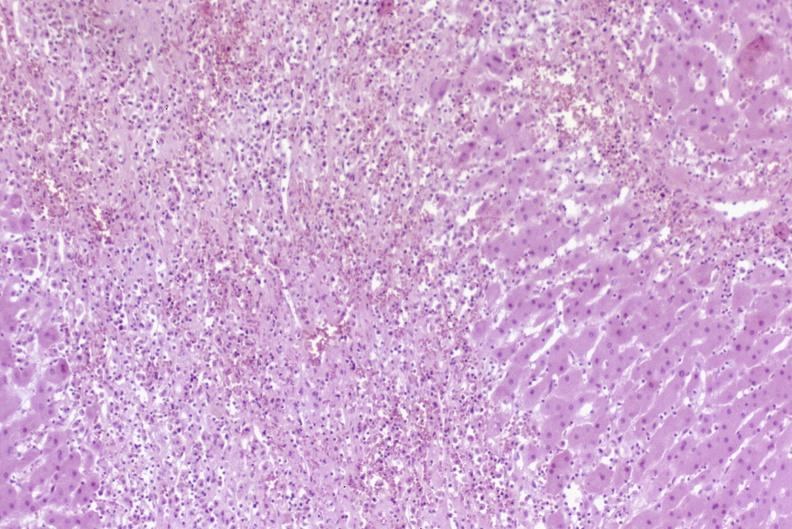s liver present?
Answer the question using a single word or phrase. Yes 